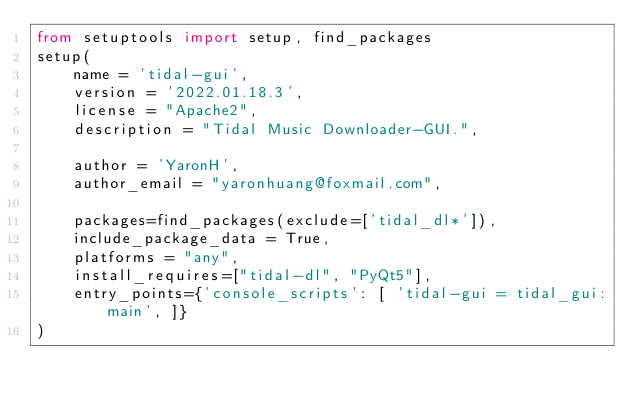Convert code to text. <code><loc_0><loc_0><loc_500><loc_500><_Python_>from setuptools import setup, find_packages
setup(
    name = 'tidal-gui',
    version = '2022.01.18.3',
    license = "Apache2",
    description = "Tidal Music Downloader-GUI.",

    author = 'YaronH',
    author_email = "yaronhuang@foxmail.com",

    packages=find_packages(exclude=['tidal_dl*']),
    include_package_data = True,
    platforms = "any",
    install_requires=["tidal-dl", "PyQt5"],
    entry_points={'console_scripts': [ 'tidal-gui = tidal_gui:main', ]}
)
</code> 